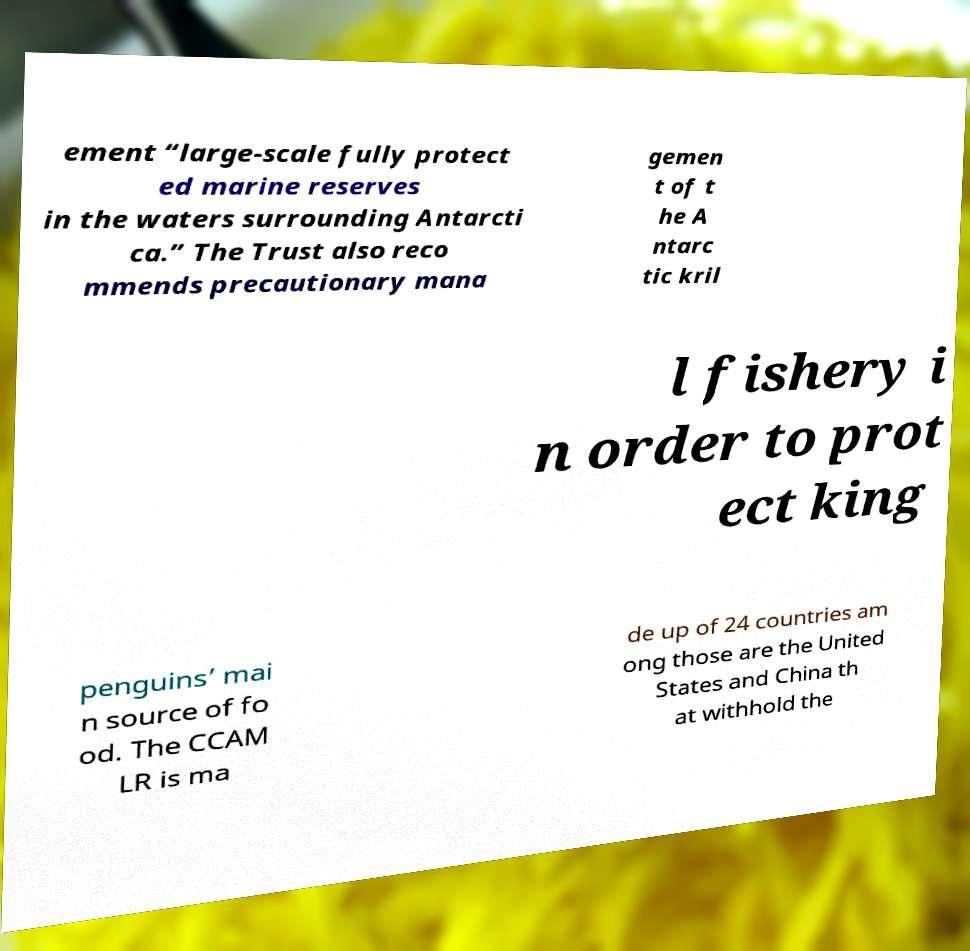Can you accurately transcribe the text from the provided image for me? ement “large-scale fully protect ed marine reserves in the waters surrounding Antarcti ca.” The Trust also reco mmends precautionary mana gemen t of t he A ntarc tic kril l fishery i n order to prot ect king penguins’ mai n source of fo od. The CCAM LR is ma de up of 24 countries am ong those are the United States and China th at withhold the 